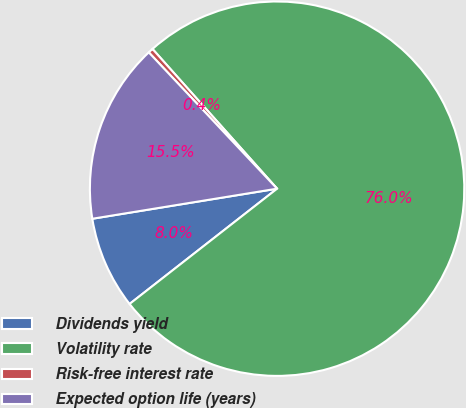Convert chart to OTSL. <chart><loc_0><loc_0><loc_500><loc_500><pie_chart><fcel>Dividends yield<fcel>Volatility rate<fcel>Risk-free interest rate<fcel>Expected option life (years)<nl><fcel>7.99%<fcel>76.04%<fcel>0.43%<fcel>15.55%<nl></chart> 